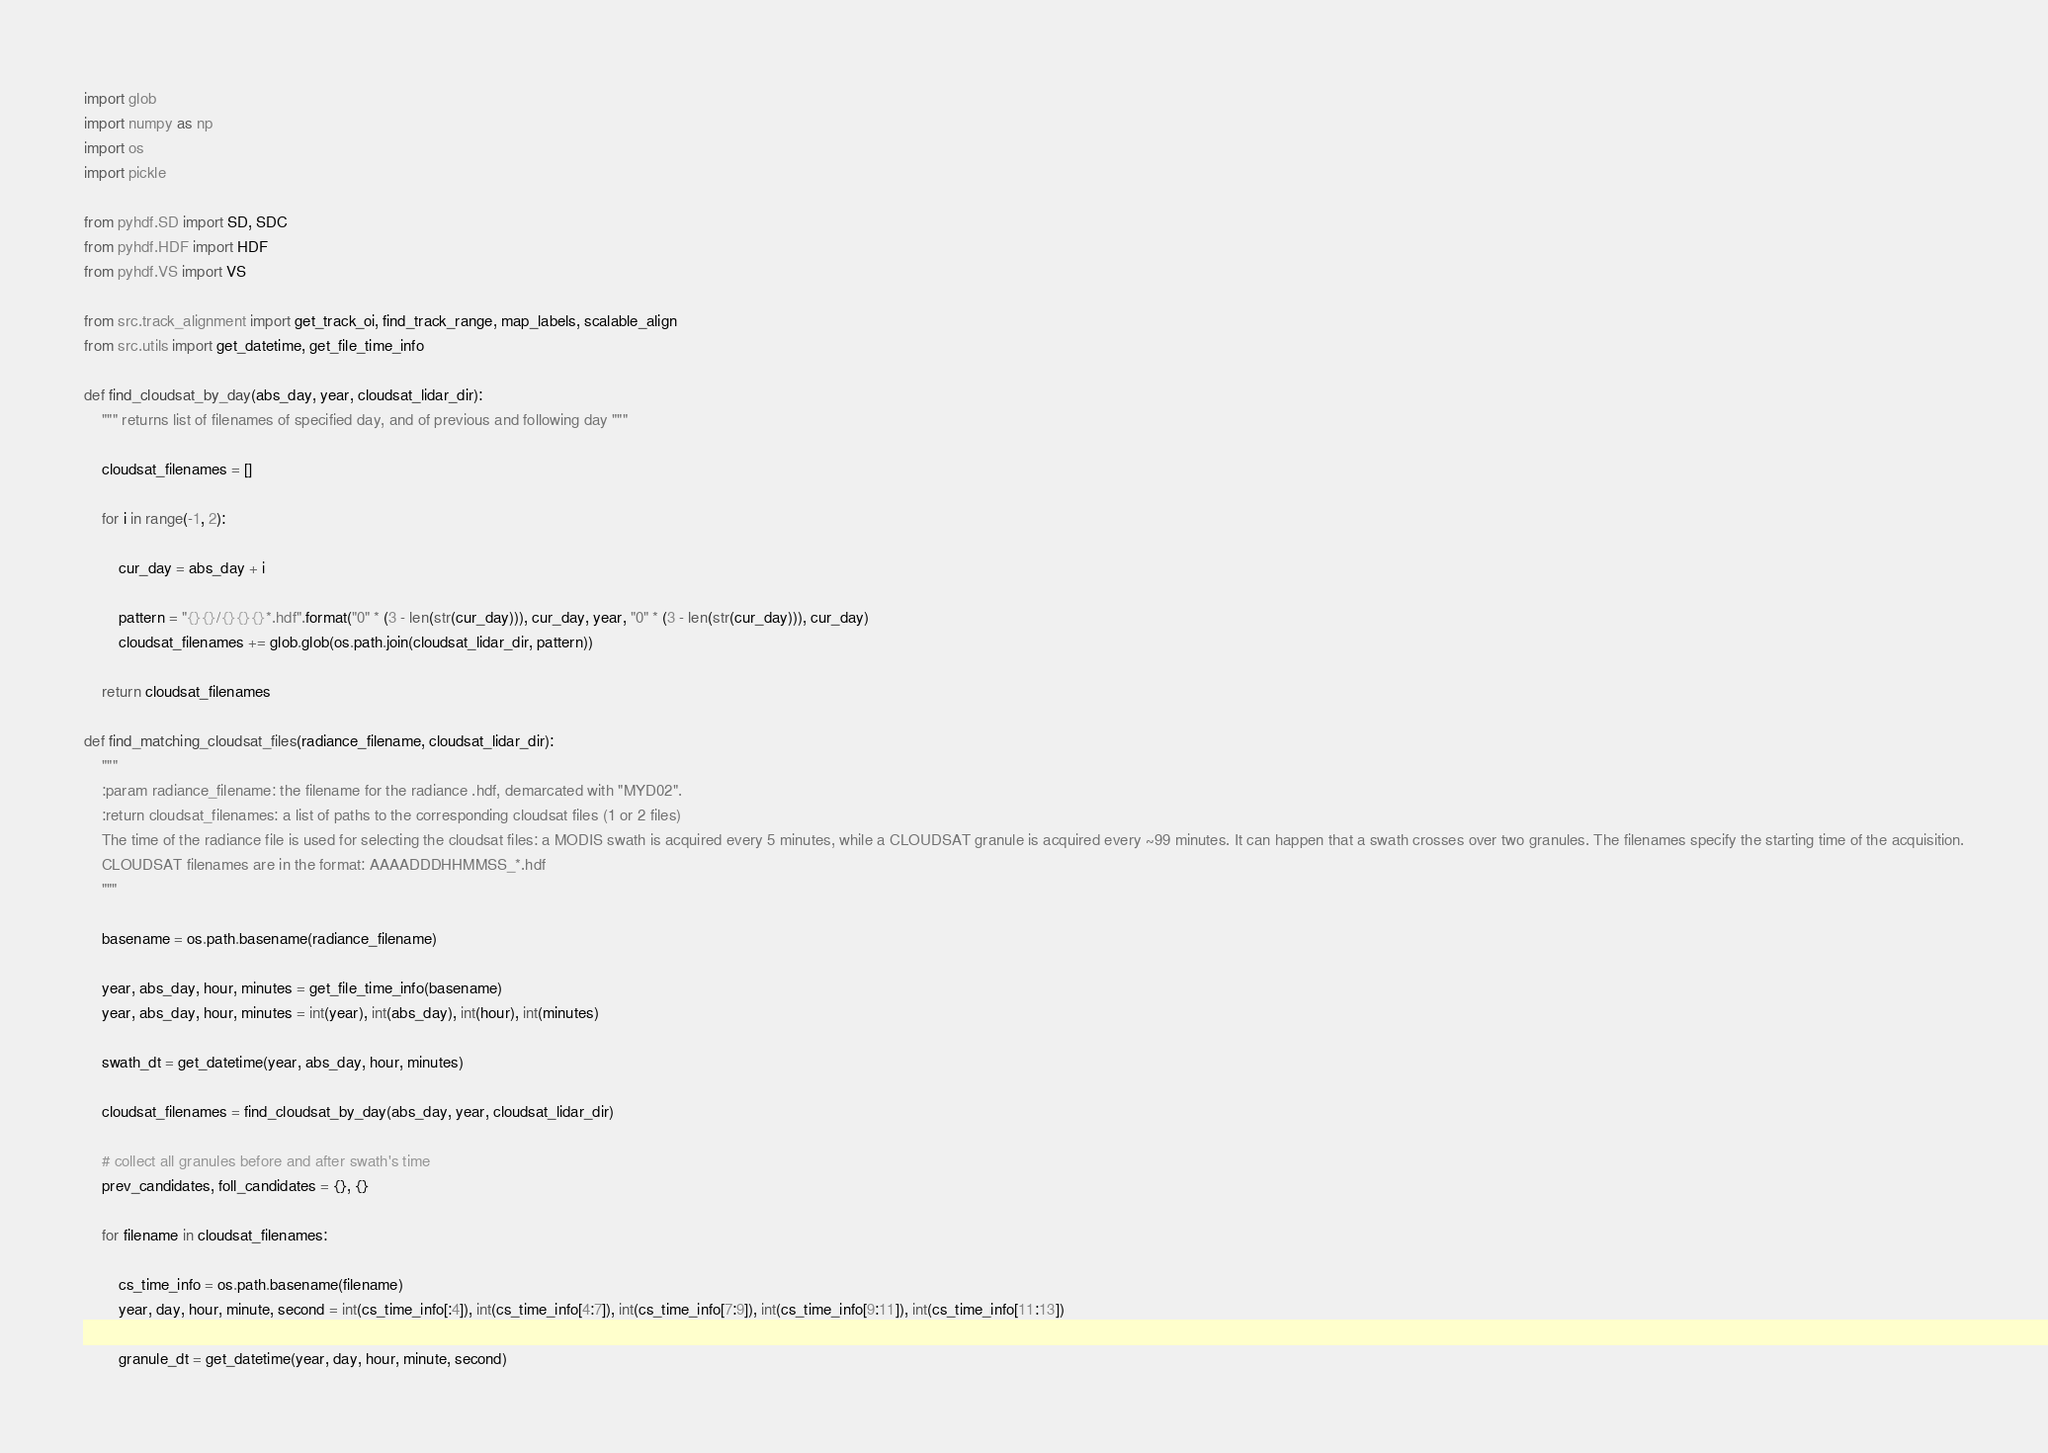Convert code to text. <code><loc_0><loc_0><loc_500><loc_500><_Python_>import glob
import numpy as np
import os
import pickle

from pyhdf.SD import SD, SDC 
from pyhdf.HDF import HDF
from pyhdf.VS import VS

from src.track_alignment import get_track_oi, find_track_range, map_labels, scalable_align
from src.utils import get_datetime, get_file_time_info

def find_cloudsat_by_day(abs_day, year, cloudsat_lidar_dir):
    """ returns list of filenames of specified day, and of previous and following day """

    cloudsat_filenames = []

    for i in range(-1, 2):
        
        cur_day = abs_day + i

        pattern = "{}{}/{}{}{}*.hdf".format("0" * (3 - len(str(cur_day))), cur_day, year, "0" * (3 - len(str(cur_day))), cur_day)
        cloudsat_filenames += glob.glob(os.path.join(cloudsat_lidar_dir, pattern))

    return cloudsat_filenames

def find_matching_cloudsat_files(radiance_filename, cloudsat_lidar_dir):
    """
    :param radiance_filename: the filename for the radiance .hdf, demarcated with "MYD02".
    :return cloudsat_filenames: a list of paths to the corresponding cloudsat files (1 or 2 files)
    The time of the radiance file is used for selecting the cloudsat files: a MODIS swath is acquired every 5 minutes, while a CLOUDSAT granule is acquired every ~99 minutes. It can happen that a swath crosses over two granules. The filenames specify the starting time of the acquisition.
    CLOUDSAT filenames are in the format: AAAADDDHHMMSS_*.hdf
    """

    basename = os.path.basename(radiance_filename)

    year, abs_day, hour, minutes = get_file_time_info(basename)
    year, abs_day, hour, minutes = int(year), int(abs_day), int(hour), int(minutes)

    swath_dt = get_datetime(year, abs_day, hour, minutes)

    cloudsat_filenames = find_cloudsat_by_day(abs_day, year, cloudsat_lidar_dir)

    # collect all granules before and after swath's time
    prev_candidates, foll_candidates = {}, {}

    for filename in cloudsat_filenames:
        
        cs_time_info = os.path.basename(filename)
        year, day, hour, minute, second = int(cs_time_info[:4]), int(cs_time_info[4:7]), int(cs_time_info[7:9]), int(cs_time_info[9:11]), int(cs_time_info[11:13])

        granule_dt = get_datetime(year, day, hour, minute, second)
</code> 